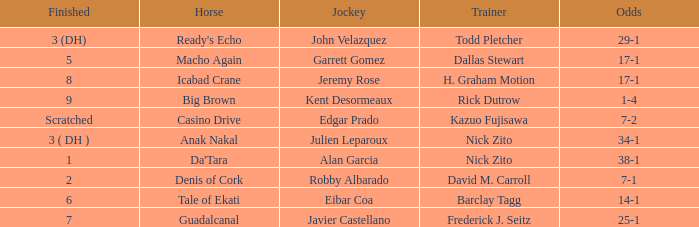What is the Finished place for da'tara trained by Nick zito? 1.0. 